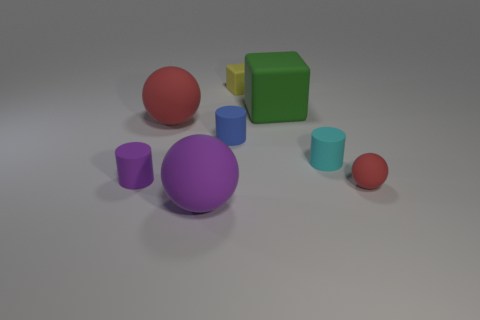Is the material of the yellow block the same as the tiny cylinder on the right side of the green matte thing?
Give a very brief answer. Yes. What number of shiny objects are either purple cylinders or large purple things?
Ensure brevity in your answer.  0. There is a purple object in front of the purple matte cylinder; what is its size?
Provide a short and direct response. Large. What size is the purple sphere that is the same material as the small block?
Make the answer very short. Large. What number of other balls have the same color as the small rubber sphere?
Your answer should be very brief. 1. Are there any big red metallic balls?
Give a very brief answer. No. Do the blue rubber object and the cyan matte object that is behind the tiny purple cylinder have the same shape?
Give a very brief answer. Yes. What color is the rubber ball right of the big object in front of the red matte sphere that is left of the green cube?
Provide a short and direct response. Red. Are there any things behind the small blue cylinder?
Your response must be concise. Yes. Is there a tiny cyan cube that has the same material as the large green object?
Provide a short and direct response. No. 